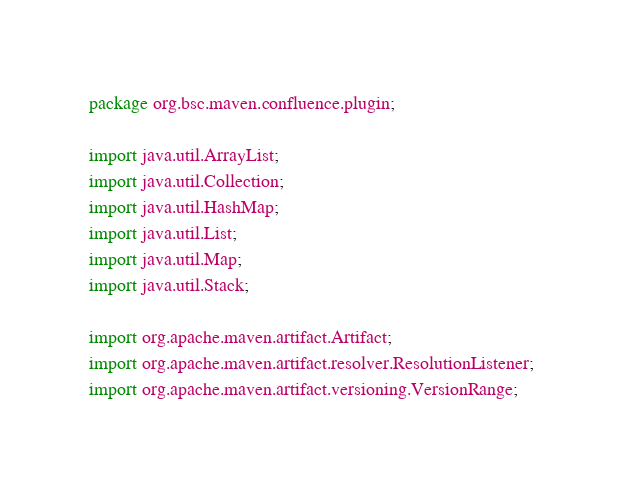Convert code to text. <code><loc_0><loc_0><loc_500><loc_500><_Java_>package org.bsc.maven.confluence.plugin;

import java.util.ArrayList;
import java.util.Collection;
import java.util.HashMap;
import java.util.List;
import java.util.Map;
import java.util.Stack;

import org.apache.maven.artifact.Artifact;
import org.apache.maven.artifact.resolver.ResolutionListener;
import org.apache.maven.artifact.versioning.VersionRange;
</code> 